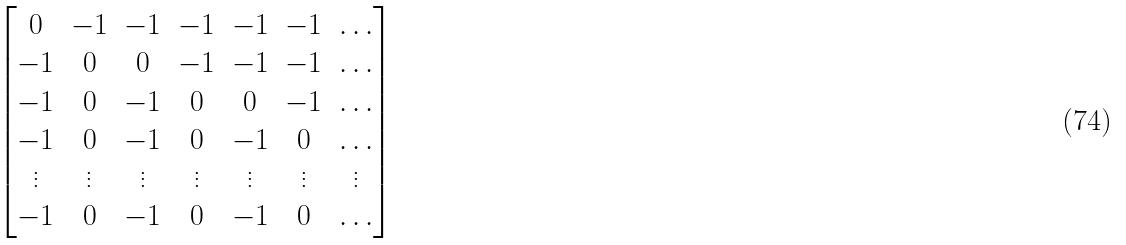Convert formula to latex. <formula><loc_0><loc_0><loc_500><loc_500>\begin{bmatrix} 0 & - 1 & - 1 & - 1 & - 1 & - 1 & \dots \\ - 1 & 0 & 0 & - 1 & - 1 & - 1 & \dots \\ - 1 & 0 & - 1 & 0 & 0 & - 1 & \dots \\ - 1 & 0 & - 1 & 0 & - 1 & 0 & \dots \\ \vdots & \vdots & \vdots & \vdots & \vdots & \vdots & \vdots \\ - 1 & 0 & - 1 & 0 & - 1 & 0 & \dots \\ \end{bmatrix}</formula> 